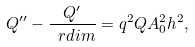<formula> <loc_0><loc_0><loc_500><loc_500>Q ^ { \prime \prime } - { \frac { Q ^ { \prime } } { \ r d i m } } = q ^ { 2 } Q A _ { 0 } ^ { 2 } h ^ { 2 } ,</formula> 